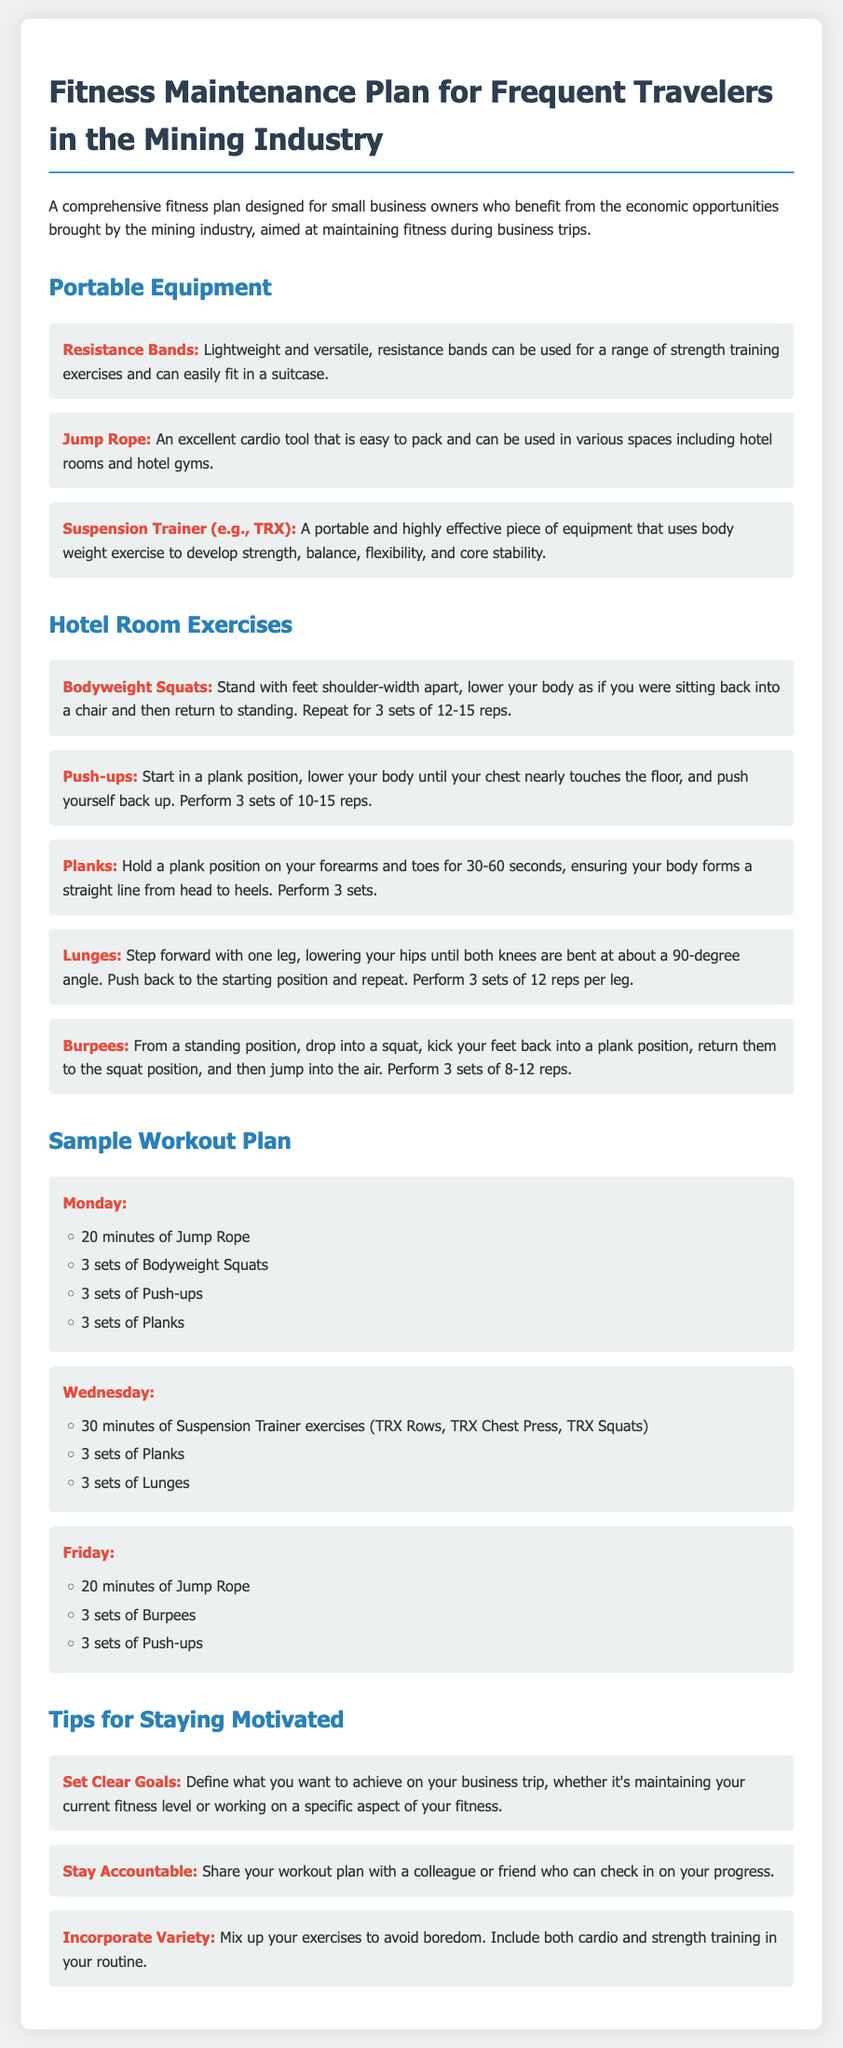What is the title of the document? The title of the document is the main heading that appears at the top, which outlines the focus of the content.
Answer: Fitness Maintenance Plan for Frequent Travelers in the Mining Industry What type of exercises are included in the hotel room exercises section? This question examines the activities outlined under the hotel room exercises, indicating the focus on bodyweight workouts.
Answer: Bodyweight How many portable equipment items are listed? This question asks for the quantity of different equipment types mentioned in the document, specifically for fitness during travel.
Answer: 3 What is the duration of the jump rope workout on Monday? The question references the specific duration mentioned in the sample workout plan for the jump rope exercise scheduled on Monday.
Answer: 20 minutes Which day includes Suspension Trainer exercises? This question identifies the specific day in the workout plan when Suspension Trainer exercises are included.
Answer: Wednesday What is a tip offered for staying motivated? The question seeks to find one of the motivational strategies provided in the tips section of the document.
Answer: Set Clear Goals How many sets of Lunges are recommended on Wednesday? This question focuses on the specific recommendation for the number of sets for a particular exercise included in the workout plan.
Answer: 3 sets Which exercise is performed on both Mondays and Fridays? This is a reasoning question that looks for a common exercise repeated on these two specific days in the workout schedule.
Answer: Push-ups What type of cardio exercise is mentioned in the portable equipment section? This question points towards a specific item related to cardiovascular fitness mentioned in the equipment section.
Answer: Jump Rope 